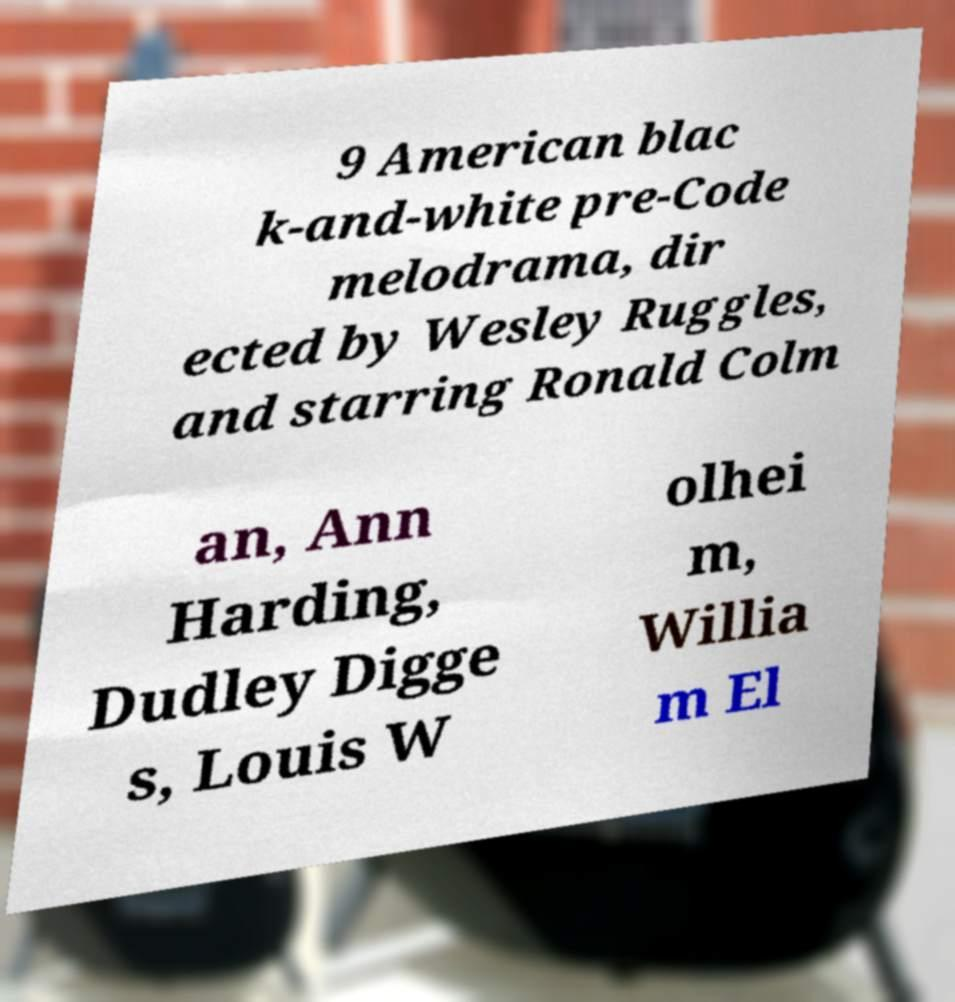I need the written content from this picture converted into text. Can you do that? 9 American blac k-and-white pre-Code melodrama, dir ected by Wesley Ruggles, and starring Ronald Colm an, Ann Harding, Dudley Digge s, Louis W olhei m, Willia m El 